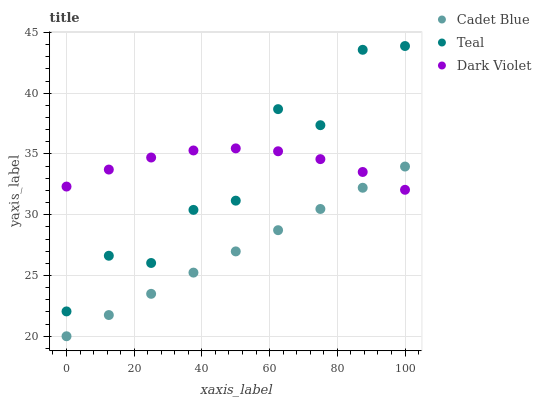Does Cadet Blue have the minimum area under the curve?
Answer yes or no. Yes. Does Dark Violet have the maximum area under the curve?
Answer yes or no. Yes. Does Teal have the minimum area under the curve?
Answer yes or no. No. Does Teal have the maximum area under the curve?
Answer yes or no. No. Is Cadet Blue the smoothest?
Answer yes or no. Yes. Is Teal the roughest?
Answer yes or no. Yes. Is Dark Violet the smoothest?
Answer yes or no. No. Is Dark Violet the roughest?
Answer yes or no. No. Does Cadet Blue have the lowest value?
Answer yes or no. Yes. Does Teal have the lowest value?
Answer yes or no. No. Does Teal have the highest value?
Answer yes or no. Yes. Does Dark Violet have the highest value?
Answer yes or no. No. Is Cadet Blue less than Teal?
Answer yes or no. Yes. Is Teal greater than Cadet Blue?
Answer yes or no. Yes. Does Dark Violet intersect Cadet Blue?
Answer yes or no. Yes. Is Dark Violet less than Cadet Blue?
Answer yes or no. No. Is Dark Violet greater than Cadet Blue?
Answer yes or no. No. Does Cadet Blue intersect Teal?
Answer yes or no. No. 